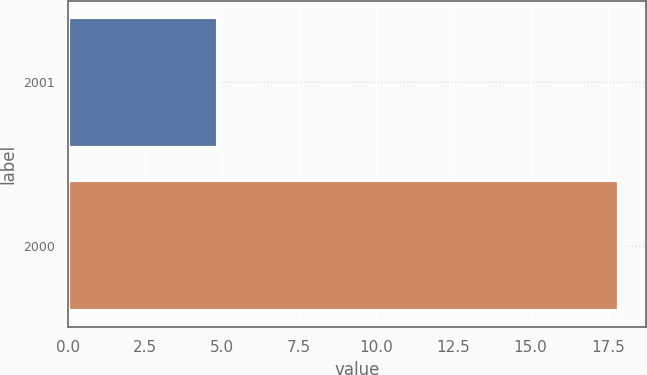Convert chart to OTSL. <chart><loc_0><loc_0><loc_500><loc_500><bar_chart><fcel>2001<fcel>2000<nl><fcel>4.87<fcel>17.86<nl></chart> 